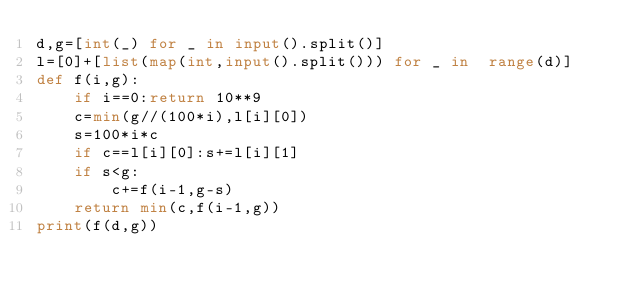Convert code to text. <code><loc_0><loc_0><loc_500><loc_500><_Python_>d,g=[int(_) for _ in input().split()]
l=[0]+[list(map(int,input().split())) for _ in  range(d)]
def f(i,g):
	if i==0:return 10**9
	c=min(g//(100*i),l[i][0])
	s=100*i*c
	if c==l[i][0]:s+=l[i][1]
	if s<g:
		c+=f(i-1,g-s)
	return min(c,f(i-1,g))
print(f(d,g))</code> 